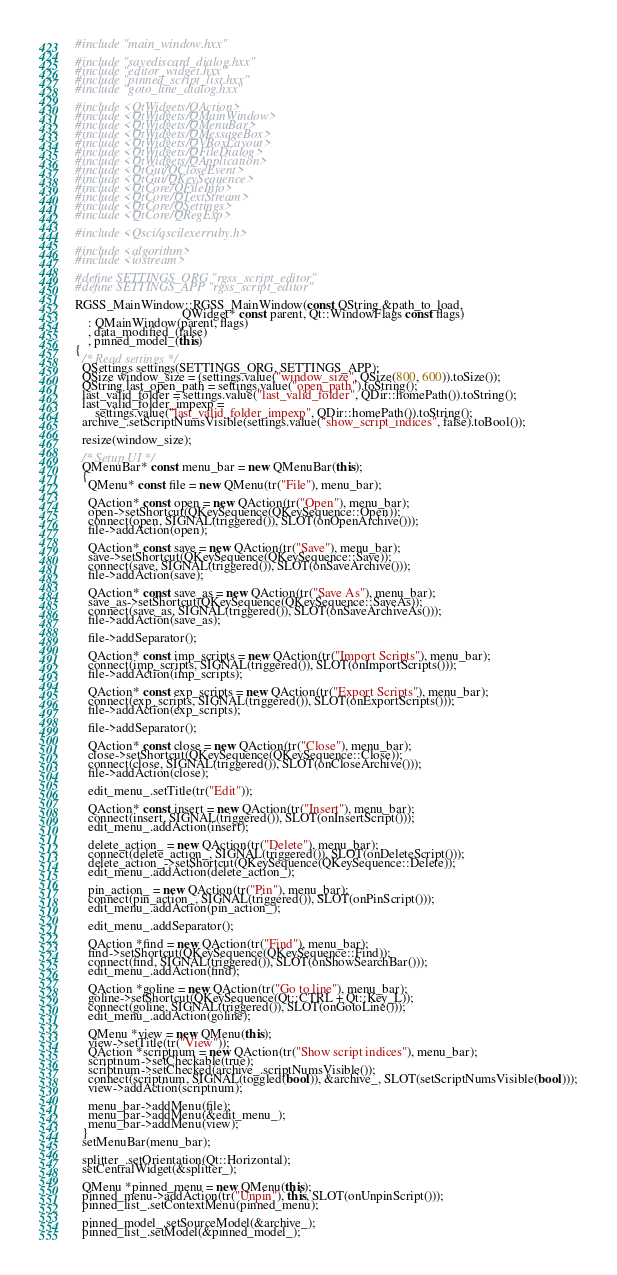<code> <loc_0><loc_0><loc_500><loc_500><_C++_>#include "main_window.hxx"

#include "savediscard_dialog.hxx"
#include "editor_widget.hxx"
#include "pinned_script_list.hxx"
#include "goto_line_dialog.hxx"

#include <QtWidgets/QAction>
#include <QtWidgets/QMainWindow>
#include <QtWidgets/QMenuBar>
#include <QtWidgets/QMessageBox>
#include <QtWidgets/QVBoxLayout>
#include <QtWidgets/QFileDialog>
#include <QtWidgets/QApplication>
#include <QtGui/QCloseEvent>
#include <QtGui/QKeySequence>
#include <QtCore/QFileInfo>
#include <QtCore/QTextStream>
#include <QtCore/QSettings>
#include <QtCore/QRegExp>

#include <Qsci/qscilexerruby.h>

#include <algorithm>
#include <iostream>

#define SETTINGS_ORG "rgss_script_editor"
#define SETTINGS_APP "rgss_script_editor"

RGSS_MainWindow::RGSS_MainWindow(const QString &path_to_load,
                                 QWidget* const parent, Qt::WindowFlags const flags)
    : QMainWindow(parent, flags)
    , data_modified_(false)
    , pinned_model_(this)
{
  /* Read settings */
  QSettings settings(SETTINGS_ORG, SETTINGS_APP);
  QSize window_size = (settings.value("window_size", QSize(800, 600)).toSize());
  QString last_open_path = settings.value("open_path").toString();
  last_valid_folder = settings.value("last_valid_folder", QDir::homePath()).toString();
  last_valid_folder_impexp =
      settings.value("last_valid_folder_impexp", QDir::homePath()).toString();
  archive_.setScriptNumsVisible(settings.value("show_script_indices", false).toBool());

  resize(window_size);

  /* Setup UI */
  QMenuBar* const menu_bar = new QMenuBar(this);
  {
    QMenu* const file = new QMenu(tr("File"), menu_bar);

    QAction* const open = new QAction(tr("Open"), menu_bar);
    open->setShortcut(QKeySequence(QKeySequence::Open));
    connect(open, SIGNAL(triggered()), SLOT(onOpenArchive()));
    file->addAction(open);

    QAction* const save = new QAction(tr("Save"), menu_bar);
    save->setShortcut(QKeySequence(QKeySequence::Save));
    connect(save, SIGNAL(triggered()), SLOT(onSaveArchive()));
    file->addAction(save);

    QAction* const save_as = new QAction(tr("Save As"), menu_bar);
    save_as->setShortcut(QKeySequence(QKeySequence::SaveAs));
    connect(save_as, SIGNAL(triggered()), SLOT(onSaveArchiveAs()));
    file->addAction(save_as);

    file->addSeparator();

    QAction* const imp_scripts = new QAction(tr("Import Scripts"), menu_bar);
    connect(imp_scripts, SIGNAL(triggered()), SLOT(onImportScripts()));
    file->addAction(imp_scripts);

    QAction* const exp_scripts = new QAction(tr("Export Scripts"), menu_bar);
    connect(exp_scripts, SIGNAL(triggered()), SLOT(onExportScripts()));
    file->addAction(exp_scripts);

    file->addSeparator();

    QAction* const close = new QAction(tr("Close"), menu_bar);
    close->setShortcut(QKeySequence(QKeySequence::Close));
    connect(close, SIGNAL(triggered()), SLOT(onCloseArchive()));
    file->addAction(close);

    edit_menu_.setTitle(tr("Edit"));

    QAction* const insert = new QAction(tr("Insert"), menu_bar);
    connect(insert, SIGNAL(triggered()), SLOT(onInsertScript()));
    edit_menu_.addAction(insert);

    delete_action_ = new QAction(tr("Delete"), menu_bar);
    connect(delete_action_, SIGNAL(triggered()), SLOT(onDeleteScript()));
    delete_action_->setShortcut(QKeySequence(QKeySequence::Delete));
    edit_menu_.addAction(delete_action_);

    pin_action_ = new QAction(tr("Pin"), menu_bar);
    connect(pin_action_, SIGNAL(triggered()), SLOT(onPinScript()));
    edit_menu_.addAction(pin_action_);

    edit_menu_.addSeparator();

    QAction *find = new QAction(tr("Find"), menu_bar);
    find->setShortcut(QKeySequence(QKeySequence::Find));
    connect(find, SIGNAL(triggered()), SLOT(onShowSearchBar()));
    edit_menu_.addAction(find);

    QAction *goline = new QAction(tr("Go to line"), menu_bar);
    goline->setShortcut(QKeySequence(Qt::CTRL + Qt::Key_L));
    connect(goline, SIGNAL(triggered()), SLOT(onGotoLine()));
    edit_menu_.addAction(goline);

    QMenu *view = new QMenu(this);
    view->setTitle(tr("View"));
    QAction *scriptnum = new QAction(tr("Show script indices"), menu_bar);
    scriptnum->setCheckable(true);
    scriptnum->setChecked(archive_.scriptNumsVisible());
    connect(scriptnum, SIGNAL(toggled(bool)), &archive_, SLOT(setScriptNumsVisible(bool)));
    view->addAction(scriptnum);

    menu_bar->addMenu(file);
    menu_bar->addMenu(&edit_menu_);
    menu_bar->addMenu(view);
  }
  setMenuBar(menu_bar);

  splitter_.setOrientation(Qt::Horizontal);
  setCentralWidget(&splitter_);

  QMenu *pinned_menu = new QMenu(this);
  pinned_menu->addAction(tr("Unpin"), this, SLOT(onUnpinScript()));
  pinned_list_.setContextMenu(pinned_menu);

  pinned_model_.setSourceModel(&archive_);
  pinned_list_.setModel(&pinned_model_);
</code> 